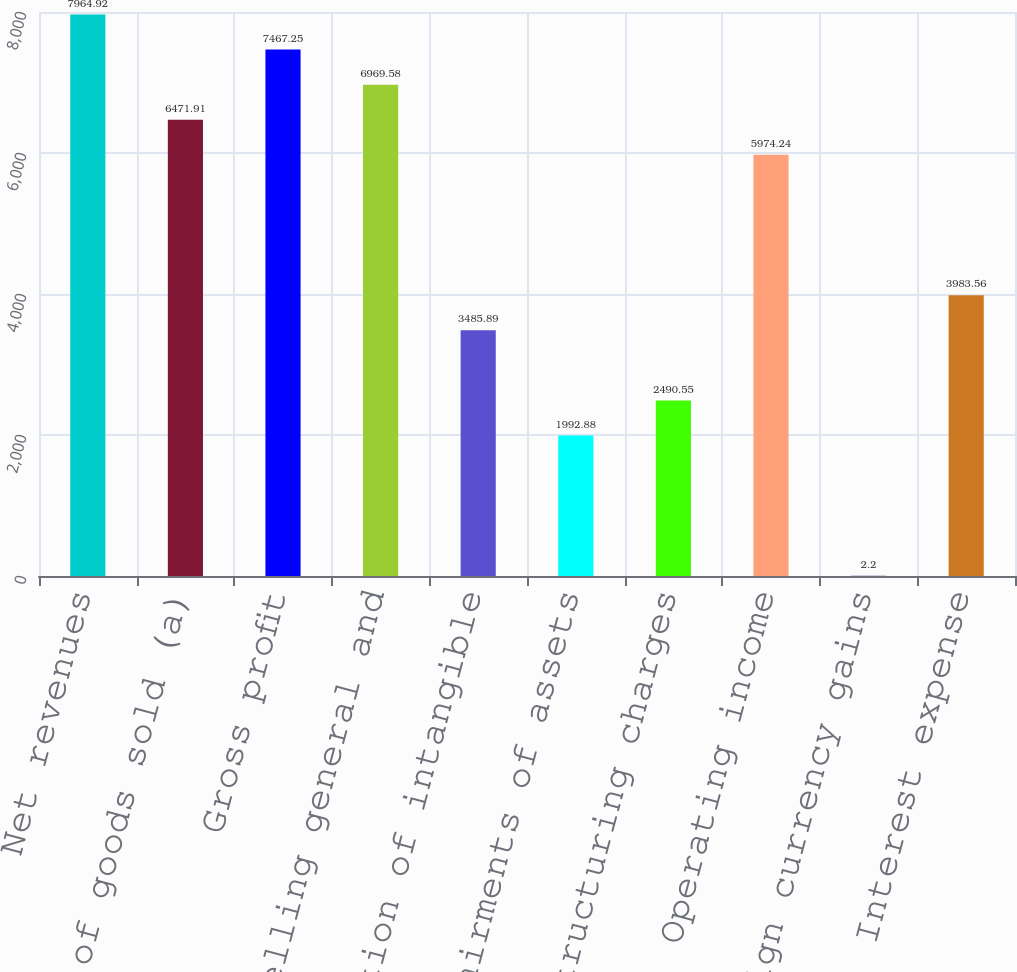<chart> <loc_0><loc_0><loc_500><loc_500><bar_chart><fcel>Net revenues<fcel>Cost of goods sold (a)<fcel>Gross profit<fcel>Selling general and<fcel>Amortization of intangible<fcel>Impairments of assets<fcel>Restructuring charges<fcel>Operating income<fcel>Foreign currency gains<fcel>Interest expense<nl><fcel>7964.92<fcel>6471.91<fcel>7467.25<fcel>6969.58<fcel>3485.89<fcel>1992.88<fcel>2490.55<fcel>5974.24<fcel>2.2<fcel>3983.56<nl></chart> 